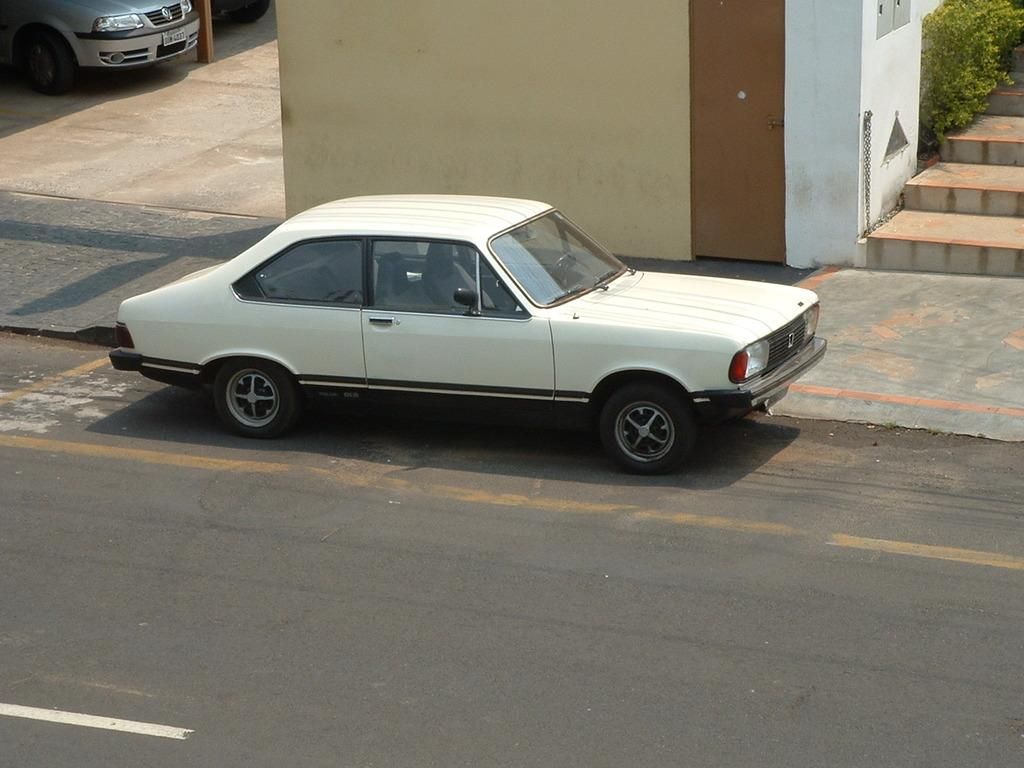What types of vehicles can be seen in the image? There are vehicles in the image, but the specific types are not mentioned. What structure is visible in the image? There is a wall in the image. Are there any architectural features in the image? Yes, there are steps in the image. What type of natural elements are present in the image? There are plants in the image. What is the primary mode of transportation visible in the image? There is a car on the road in the image. Can you hear the bells ringing in the image? There is no mention of bells in the image, so it is not possible to hear them ringing. Is there a cushion visible in the image? There is no mention of a cushion in the image, so it is not possible to determine if one is visible. 